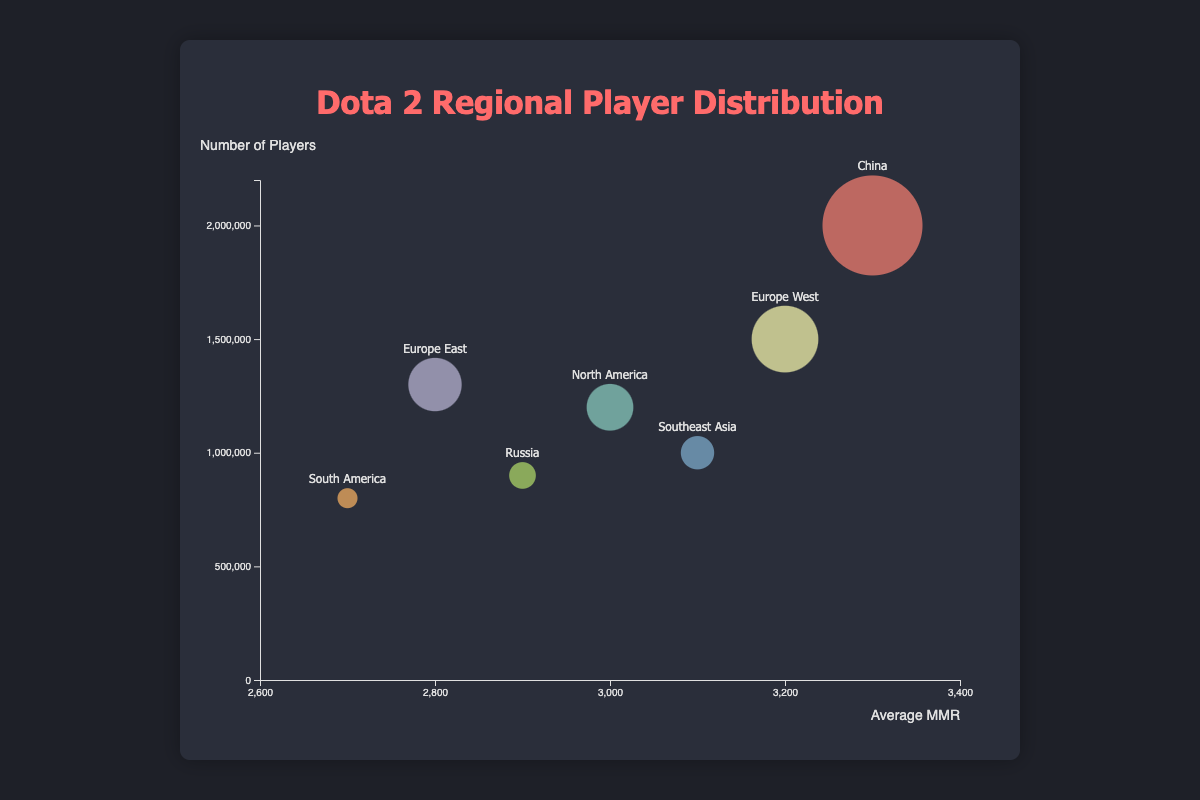What region has the highest average MMR? The bubble chart clearly shows that the region with the highest vertical position among all regions is China with an average MMR of 3300.
Answer: China Which region has the largest number of players? By looking at the bubble sizes, the region with the largest bubble is China with 2,000,000 players.
Answer: China What is the total number of players in North America and Russia combined? The number of players in North America is 1,200,000 and in Russia is 900,000. Adding them up gives 1,200,000 + 900,000 = 2,100,000.
Answer: 2,100,000 Which region has a higher average MMR, Southeast Asia or North America? Southeast Asia has an average MMR of 3100 while North America has an average MMR of 3000, so Southeast Asia has a higher average MMR.
Answer: Southeast Asia What is the difference in the number of players between Europe West and South America? Europe West has 1,500,000 players while South America has 800,000 players. The difference is 1,500,000 - 800,000 = 700,000.
Answer: 700,000 Which region has the lowest average MMR? The region with the lowest vertically placed bubble representing average MMR is South America with an MMR of 2700.
Answer: South America How many regions have an average MMR greater than 3000? By looking at the bubbles positioned above the 3000 MMR line, we find that Europe West, China, and Southeast Asia have average MMRs greater than 3000.
Answer: 3 If you combined the players from Europe East and Russia, how many players would there be? Europe East has 1,300,000 players and Russia has 900,000 players, combining them gives 1,300,000 + 900,000 = 2,200,000.
Answer: 2,200,000 Which region has the lowest number of players, and what is the number? The smallest bubble on the chart represents South America with 800,000 players.
Answer: South America What is the average MMR among all seven regions provided? Summing the average MMRs: 3000 (NA) + 3200 (EU W) + 2800 (EU E) + 3300 (China) + 3100 (SEA) + 2700 (SA) + 2900 (Russia) = 21000. Dividing by the number of regions gives 21000 / 7 = 3000.
Answer: 3000 